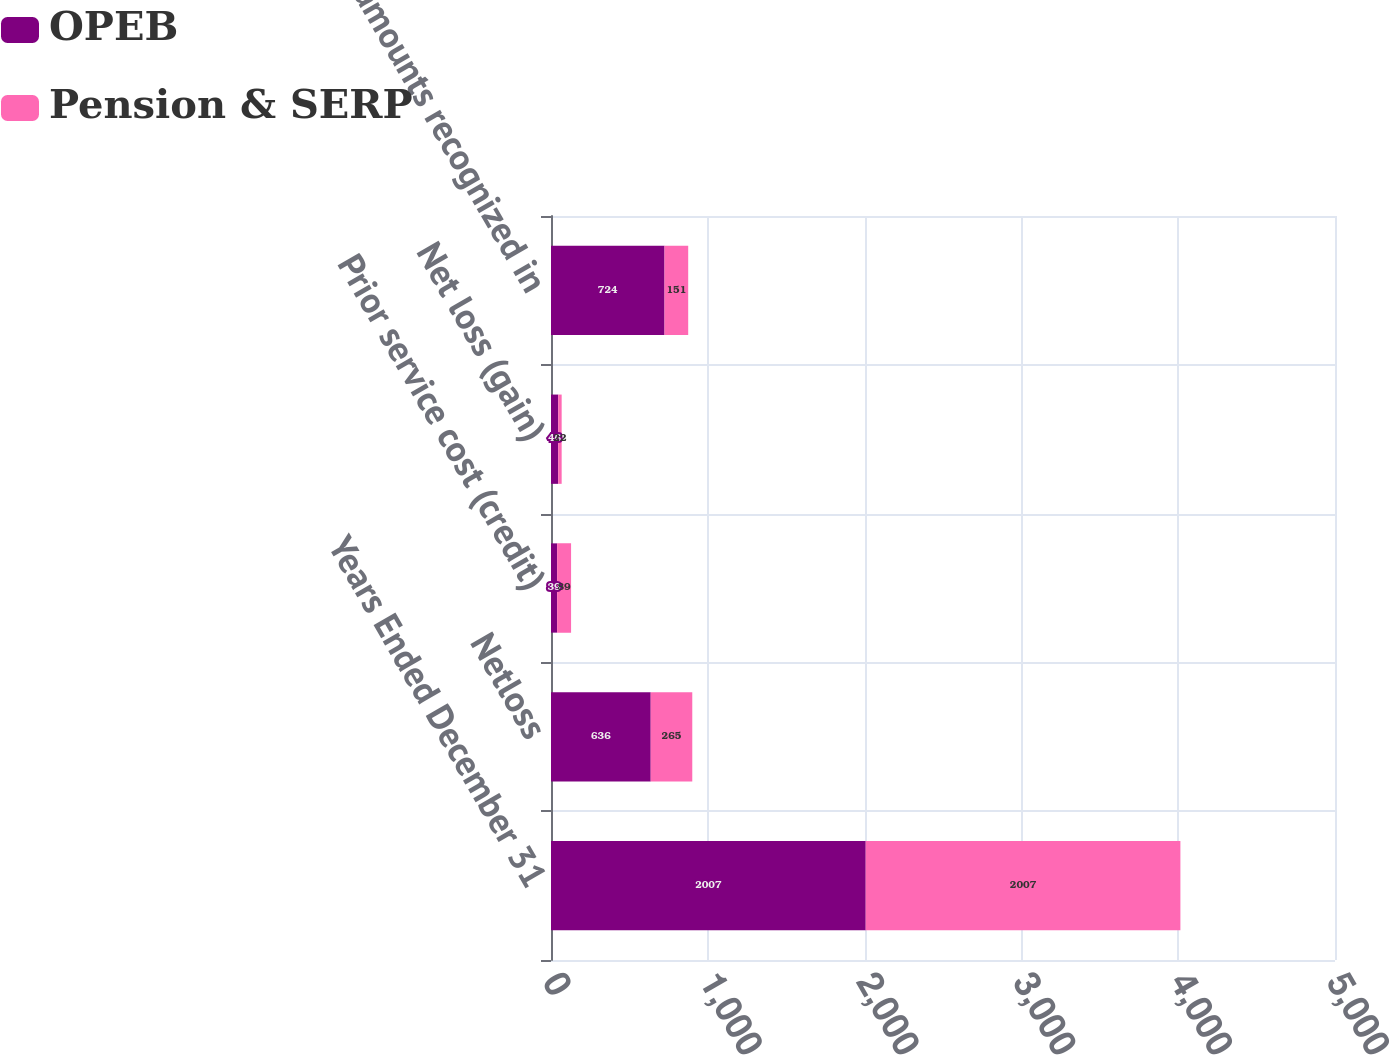Convert chart. <chart><loc_0><loc_0><loc_500><loc_500><stacked_bar_chart><ecel><fcel>Years Ended December 31<fcel>Netloss<fcel>Prior service cost (credit)<fcel>Net loss (gain)<fcel>Total amounts recognized in<nl><fcel>OPEB<fcel>2007<fcel>636<fcel>39<fcel>46<fcel>724<nl><fcel>Pension & SERP<fcel>2007<fcel>265<fcel>89<fcel>22<fcel>151<nl></chart> 